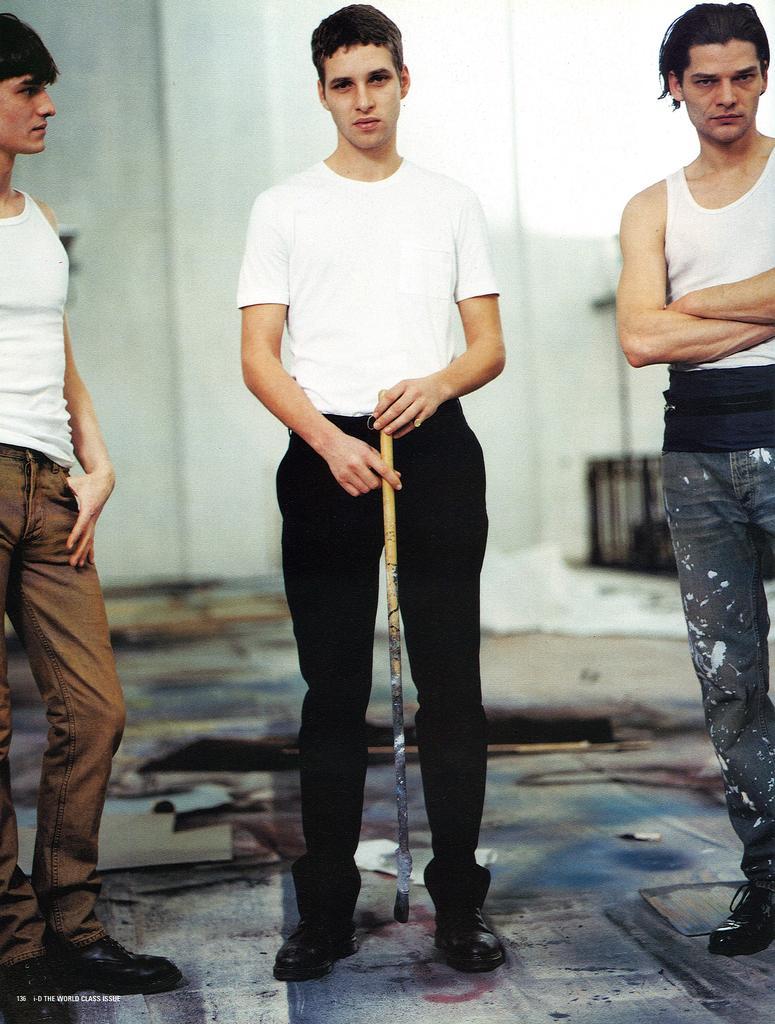Could you give a brief overview of what you see in this image? In the picture we can see three men are standing and one man is holding a stick and behind them we can see the wall. 